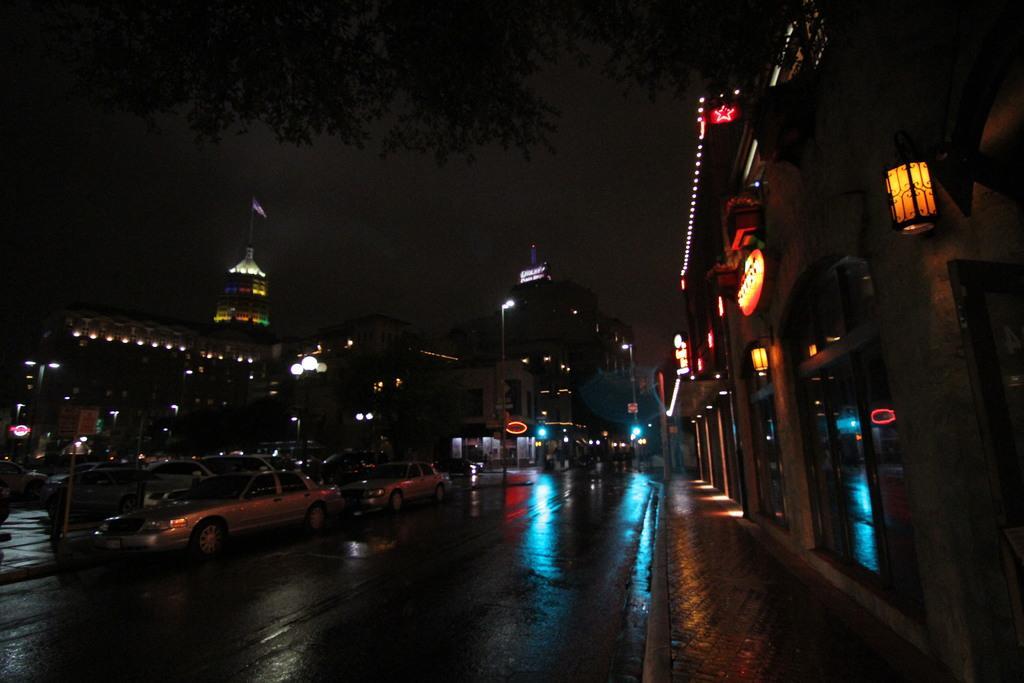Please provide a concise description of this image. These are the cars on the road. I can see the buildings with lights and glass doors. This looks like a flag, which is hanging to the pole. I think this is the tree. I can see the street lights. 